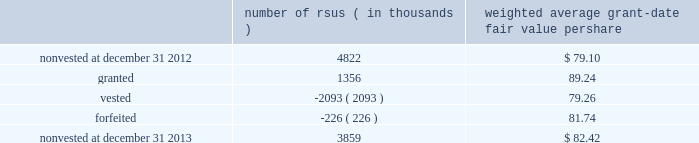Note 12 2013 stock-based compensation during 2013 , 2012 , and 2011 , we recorded non-cash stock-based compensation expense totaling $ 189 million , $ 167 million , and $ 157 million , which is included as a component of other unallocated costs on our statements of earnings .
The net impact to earnings for the respective years was $ 122 million , $ 108 million , and $ 101 million .
As of december 31 , 2013 , we had $ 132 million of unrecognized compensation cost related to nonvested awards , which is expected to be recognized over a weighted average period of 1.5 years .
We received cash from the exercise of stock options totaling $ 827 million , $ 440 million , and $ 116 million during 2013 , 2012 , and 2011 .
In addition , our income tax liabilities for 2013 , 2012 , and 2011 were reduced by $ 158 million , $ 96 million , and $ 56 million due to recognized tax benefits on stock-based compensation arrangements .
Stock-based compensation plans under plans approved by our stockholders , we are authorized to grant key employees stock-based incentive awards , including options to purchase common stock , stock appreciation rights , restricted stock units ( rsus ) , performance stock units ( psus ) , or other stock units .
The exercise price of options to purchase common stock may not be less than the fair market value of our stock on the date of grant .
No award of stock options may become fully vested prior to the third anniversary of the grant , and no portion of a stock option grant may become vested in less than one year .
The minimum vesting period for restricted stock or stock units payable in stock is three years .
Award agreements may provide for shorter or pro-rated vesting periods or vesting following termination of employment in the case of death , disability , divestiture , retirement , change of control , or layoff .
The maximum term of a stock option or any other award is 10 years .
At december 31 , 2013 , inclusive of the shares reserved for outstanding stock options , rsus and psus , we had 20.4 million shares reserved for issuance under the plans .
At december 31 , 2013 , 4.7 million of the shares reserved for issuance remained available for grant under our stock-based compensation plans .
We issue new shares upon the exercise of stock options or when restrictions on rsus and psus have been satisfied .
The table summarizes activity related to nonvested rsus during 2013 : number of rsus ( in thousands ) weighted average grant-date fair value per share .
Rsus are valued based on the fair value of our common stock on the date of grant .
Employees who are granted rsus receive the right to receive shares of stock after completion of the vesting period , however , the shares are not issued , and the employees cannot sell or transfer shares prior to vesting and have no voting rights until the rsus vest , generally three years from the date of the award .
Employees who are granted rsus receive dividend-equivalent cash payments only upon vesting .
For these rsu awards , the grant-date fair value is equal to the closing market price of our common stock on the date of grant less a discount to reflect the delay in payment of dividend-equivalent cash payments .
We recognize the grant-date fair value of rsus , less estimated forfeitures , as compensation expense ratably over the requisite service period , which beginning with the rsus granted in 2013 is shorter than the vesting period if the employee is retirement eligible on the date of grant or will become retirement eligible before the end of the vesting period .
Stock options we generally recognize compensation cost for stock options ratably over the three-year vesting period .
At december 31 , 2013 and 2012 , there were 10.2 million ( weighted average exercise price of $ 83.65 ) and 20.6 million ( weighted average exercise price of $ 83.15 ) stock options outstanding .
Stock options outstanding at december 31 , 2013 have a weighted average remaining contractual life of approximately five years and an aggregate intrinsic value of $ 663 million , and we expect nearly all of these stock options to vest .
Of the stock options outstanding , 7.7 million ( weighted average exercise price of $ 84.37 ) have vested as of december 31 , 2013 and those stock options have a weighted average remaining contractual life of approximately four years and an aggregate intrinsic value of $ 497 million .
There were 10.1 million ( weighted average exercise price of $ 82.72 ) stock options exercised during 2013 .
We did not grant stock options to employees during 2013. .
What was the difference in the weighted average grant-date fair value per share between 2012 and 2013?\\n? 
Computations: (82.42 - 79.10)
Answer: 3.32. 